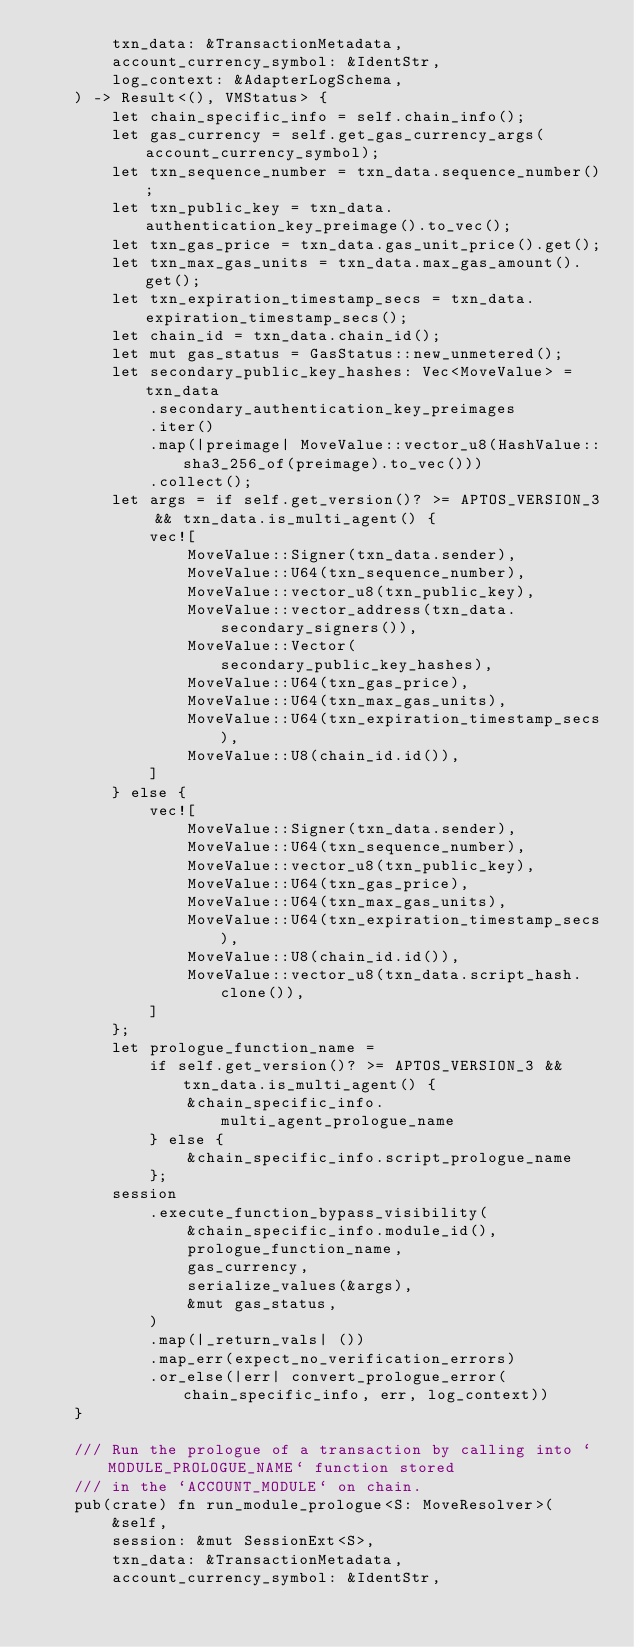Convert code to text. <code><loc_0><loc_0><loc_500><loc_500><_Rust_>        txn_data: &TransactionMetadata,
        account_currency_symbol: &IdentStr,
        log_context: &AdapterLogSchema,
    ) -> Result<(), VMStatus> {
        let chain_specific_info = self.chain_info();
        let gas_currency = self.get_gas_currency_args(account_currency_symbol);
        let txn_sequence_number = txn_data.sequence_number();
        let txn_public_key = txn_data.authentication_key_preimage().to_vec();
        let txn_gas_price = txn_data.gas_unit_price().get();
        let txn_max_gas_units = txn_data.max_gas_amount().get();
        let txn_expiration_timestamp_secs = txn_data.expiration_timestamp_secs();
        let chain_id = txn_data.chain_id();
        let mut gas_status = GasStatus::new_unmetered();
        let secondary_public_key_hashes: Vec<MoveValue> = txn_data
            .secondary_authentication_key_preimages
            .iter()
            .map(|preimage| MoveValue::vector_u8(HashValue::sha3_256_of(preimage).to_vec()))
            .collect();
        let args = if self.get_version()? >= APTOS_VERSION_3 && txn_data.is_multi_agent() {
            vec![
                MoveValue::Signer(txn_data.sender),
                MoveValue::U64(txn_sequence_number),
                MoveValue::vector_u8(txn_public_key),
                MoveValue::vector_address(txn_data.secondary_signers()),
                MoveValue::Vector(secondary_public_key_hashes),
                MoveValue::U64(txn_gas_price),
                MoveValue::U64(txn_max_gas_units),
                MoveValue::U64(txn_expiration_timestamp_secs),
                MoveValue::U8(chain_id.id()),
            ]
        } else {
            vec![
                MoveValue::Signer(txn_data.sender),
                MoveValue::U64(txn_sequence_number),
                MoveValue::vector_u8(txn_public_key),
                MoveValue::U64(txn_gas_price),
                MoveValue::U64(txn_max_gas_units),
                MoveValue::U64(txn_expiration_timestamp_secs),
                MoveValue::U8(chain_id.id()),
                MoveValue::vector_u8(txn_data.script_hash.clone()),
            ]
        };
        let prologue_function_name =
            if self.get_version()? >= APTOS_VERSION_3 && txn_data.is_multi_agent() {
                &chain_specific_info.multi_agent_prologue_name
            } else {
                &chain_specific_info.script_prologue_name
            };
        session
            .execute_function_bypass_visibility(
                &chain_specific_info.module_id(),
                prologue_function_name,
                gas_currency,
                serialize_values(&args),
                &mut gas_status,
            )
            .map(|_return_vals| ())
            .map_err(expect_no_verification_errors)
            .or_else(|err| convert_prologue_error(chain_specific_info, err, log_context))
    }

    /// Run the prologue of a transaction by calling into `MODULE_PROLOGUE_NAME` function stored
    /// in the `ACCOUNT_MODULE` on chain.
    pub(crate) fn run_module_prologue<S: MoveResolver>(
        &self,
        session: &mut SessionExt<S>,
        txn_data: &TransactionMetadata,
        account_currency_symbol: &IdentStr,</code> 